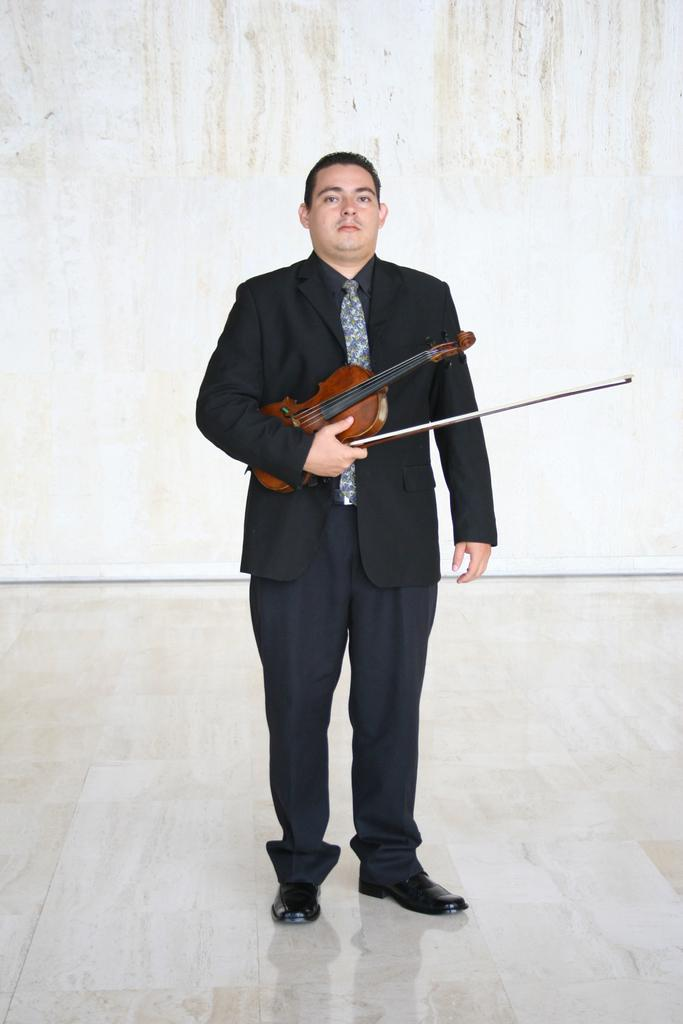What is the main subject of the image? The main subject of the image is a man. What is the man doing in the image? The man is standing on the floor and holding a violin in his hand. What can be seen in the background of the image? There is a wall in the background of the image. What type of bulb is hanging from the ceiling in the image? There is no bulb present in the image; it only features a man standing on the floor and holding a violin. Can you tell me the color of the vase on the table in the image? There is no table or vase present in the image. 